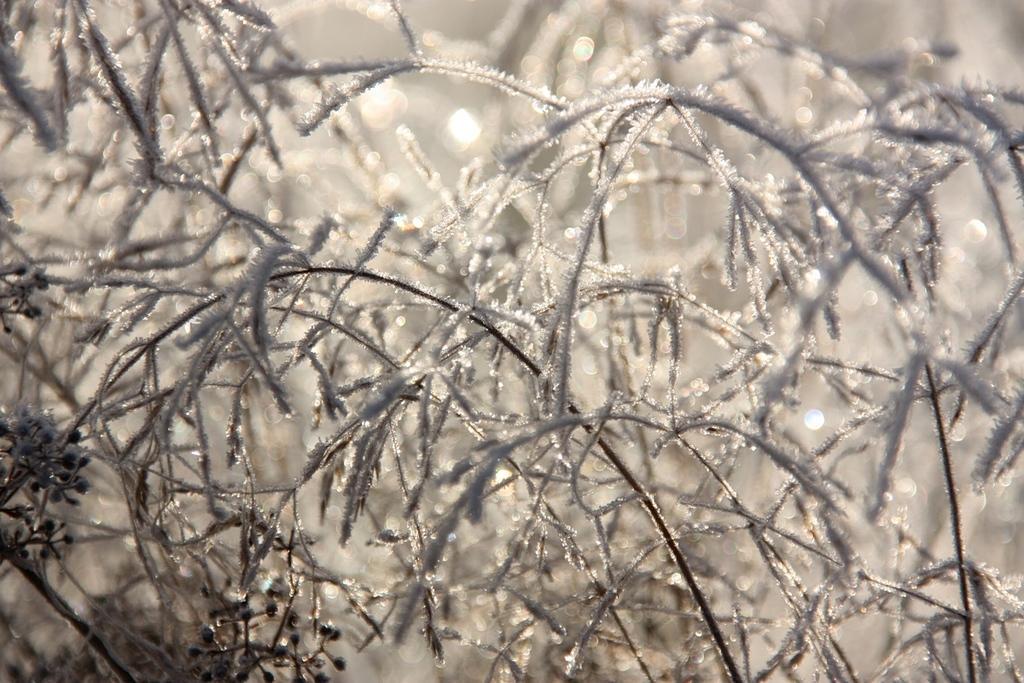Please provide a concise description of this image. In this image we can see a group of plants. 